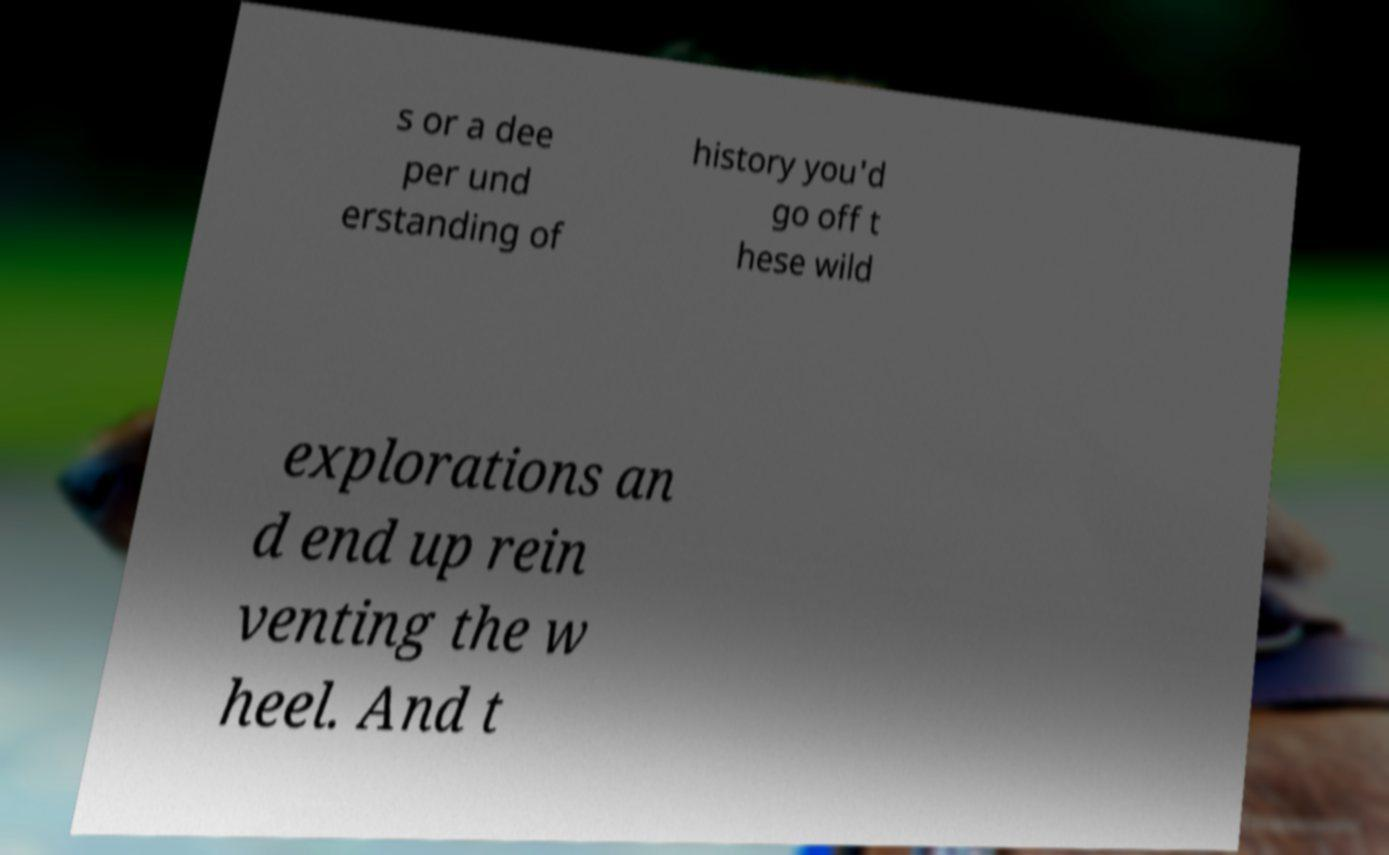Can you read and provide the text displayed in the image?This photo seems to have some interesting text. Can you extract and type it out for me? s or a dee per und erstanding of history you'd go off t hese wild explorations an d end up rein venting the w heel. And t 